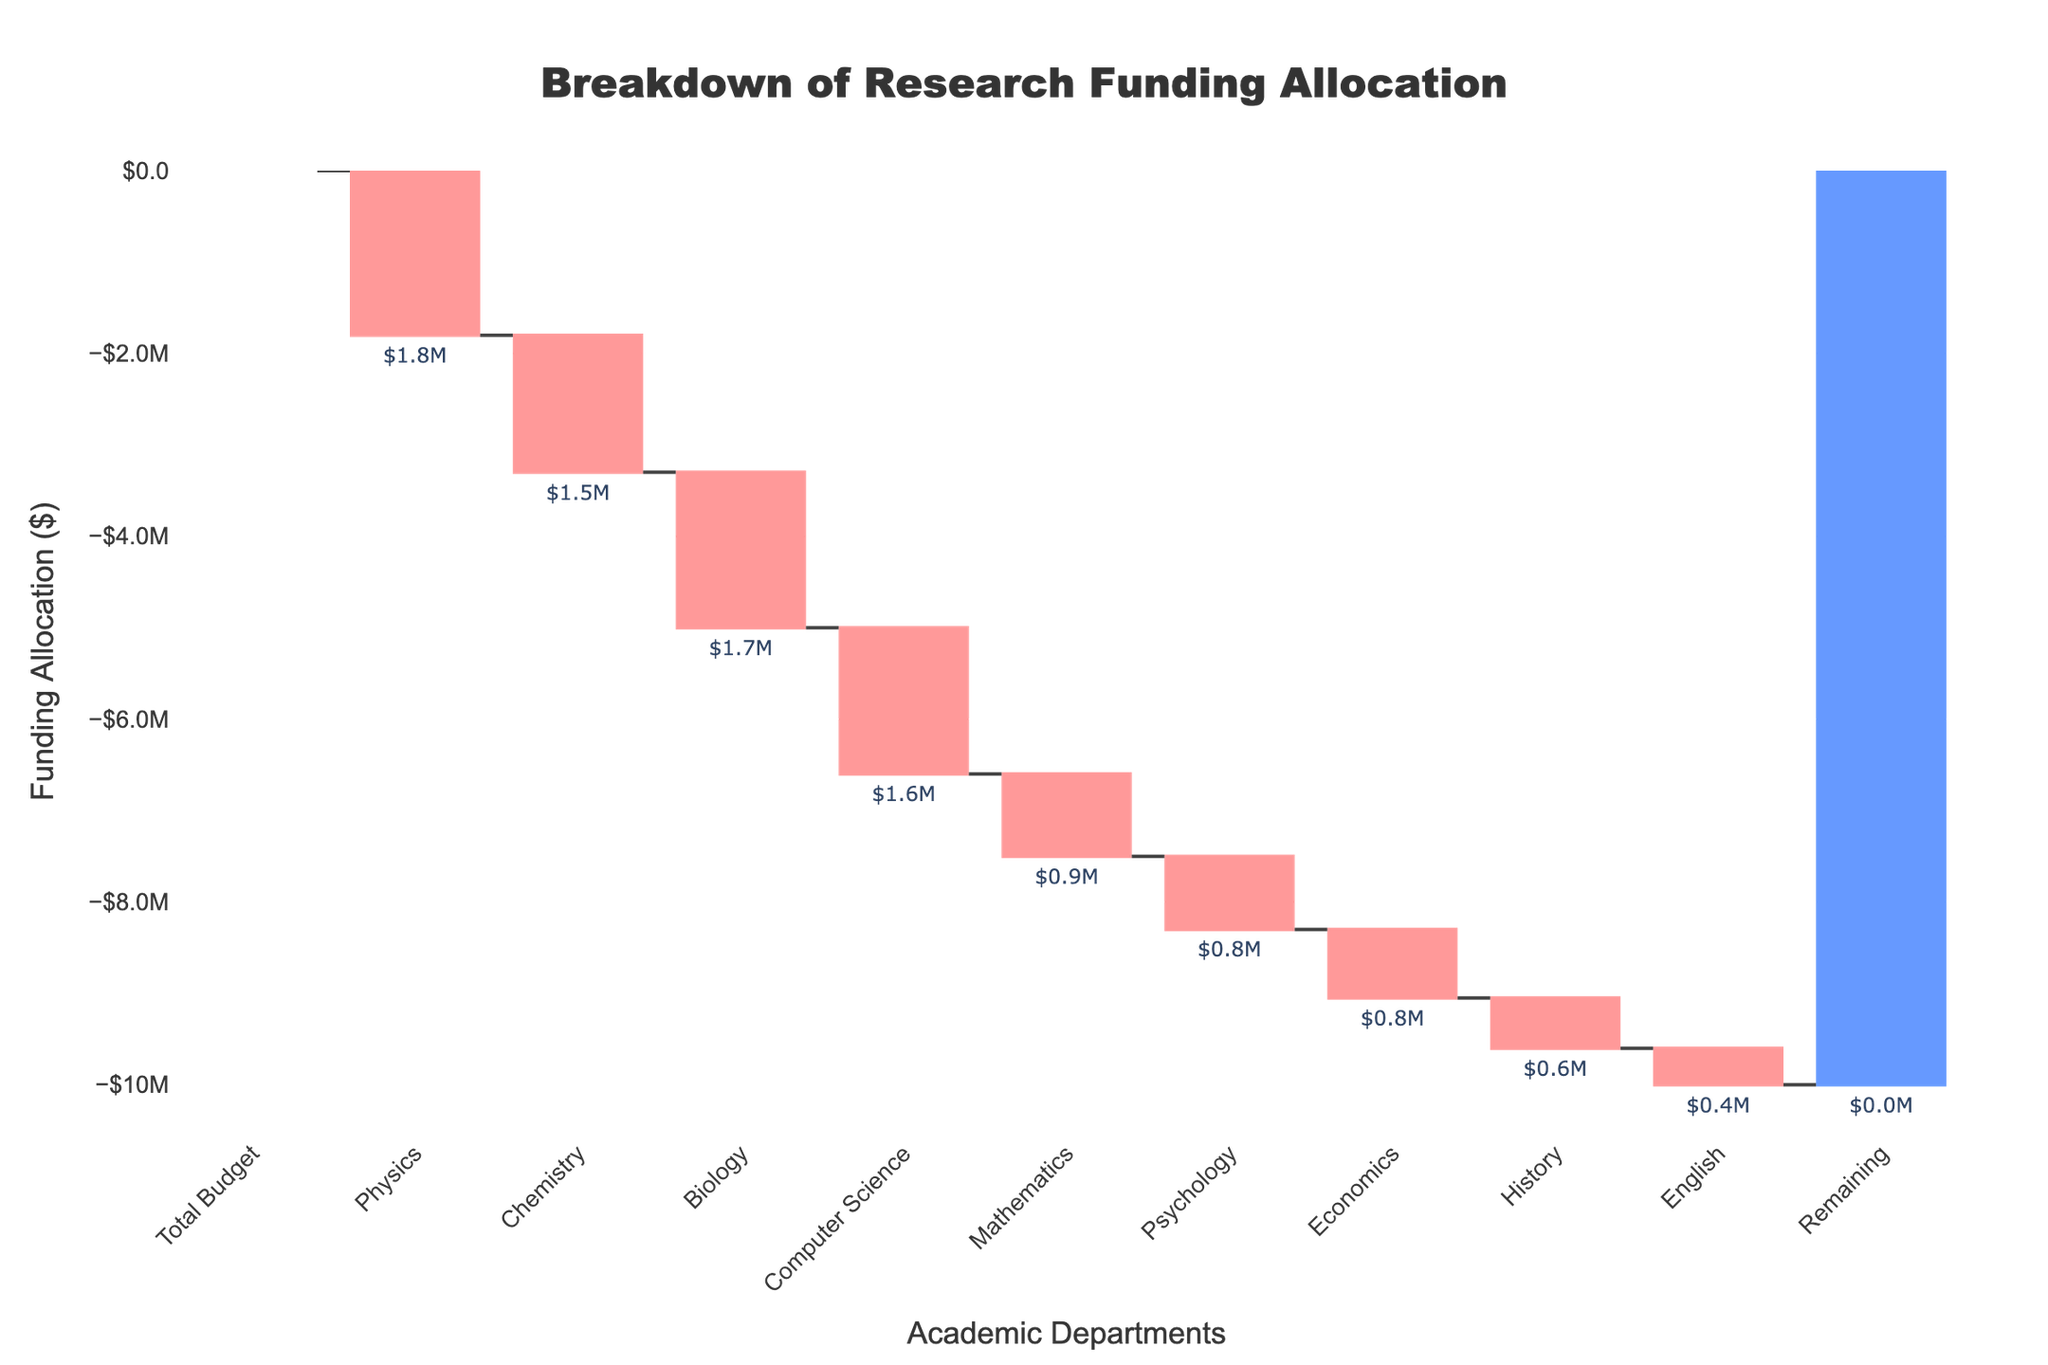What is the total budget for research funding according to the chart? The title of the chart indicates that it shows a breakdown of research funding allocation, and the bar labeled "Total Budget" represents the total amount available. The value above this bar shows the total budget.
Answer: $10,000,000 Which academic department received the highest allocation? By examining the bars in the Waterfall Chart, one can identify the department with the highest absolute value of allocation. The Physics department has the largest negative value, meaning it received the highest allocation.
Answer: Physics What is the difference in funding between the Biology and Chemistry departments? The chart shows the funding allocation for each department. The Biology department received $1,700,000, while the Chemistry department received $1,500,000. The difference between them is the absolute difference.
Answer: $200,000 What are the total funds allocated to the Mathematics, Psychology, and Economics departments combined? Adding up the individual allocations for Mathematics ($900,000), Psychology ($800,000), and Economics ($750,000) departments, we calculate the total funding for these three departments.
Answer: $2,450,000 How does the allocation for the Computer Science department compare to the allocation for the History department? Compared to the History department's allocation of $550,000, the Computer Science department received $1,600,000. We compare the two values to see the difference or the greater value.
Answer: Computer Science received more What is the sum of allocations for all departments besides Physics? To find the total allocation without the Physics department, sum the allocations for all other departments: Chemistry ($1,500,000), Biology ($1,700,000), Computer Science ($1,600,000), Mathematics ($900,000), Psychology ($800,000), Economics ($750,000), History ($550,000), and English ($400,000).
Answer: $8,200,000 What is the average funding allocation per department excluding the total budget and remaining amount? First, sum the allocations for all the departments: $1,800,000 + $1,500,000 + $1,700,000 + $1,600,000 + $900,000 + $800,000 + $750,000 + $550,000 + $400,000. Then, divide by the number of departments (9).
Answer: $1,066,667 Which department received the least amount of funding, and how much was it? The chart shows the allocations for each department, and the bar with the smallest value indicates the least amount of funding. The English department received the least funding.
Answer: English, $400,000 What is the total funding remaining after allocations? The bar labeled "Remaining" indicates the remaining funds after all the allocations have been made. According to the chart, the remaining amount is shown next to this bar.
Answer: $0 